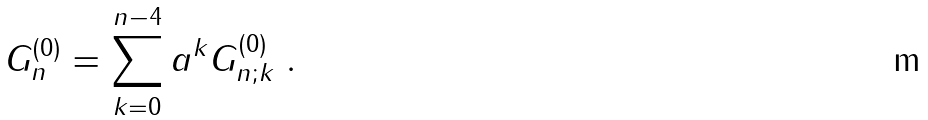Convert formula to latex. <formula><loc_0><loc_0><loc_500><loc_500>G ^ { ( 0 ) } _ { n } = \sum _ { k = 0 } ^ { n - 4 } a ^ { k } G ^ { ( 0 ) } _ { n ; k } \ .</formula> 